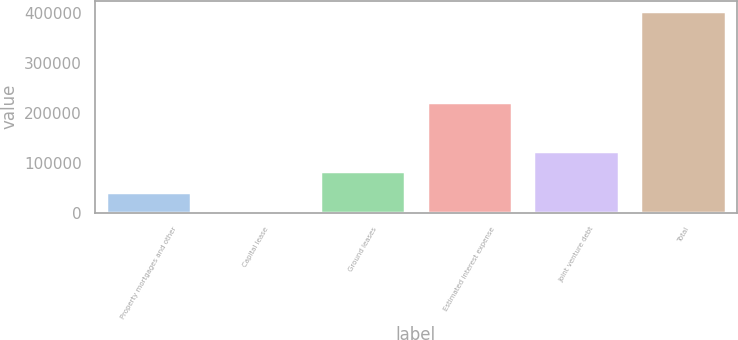<chart> <loc_0><loc_0><loc_500><loc_500><bar_chart><fcel>Property mortgages and other<fcel>Capital lease<fcel>Ground leases<fcel>Estimated interest expense<fcel>Joint venture debt<fcel>Total<nl><fcel>42676.6<fcel>2411<fcel>82942.2<fcel>222554<fcel>123208<fcel>405067<nl></chart> 